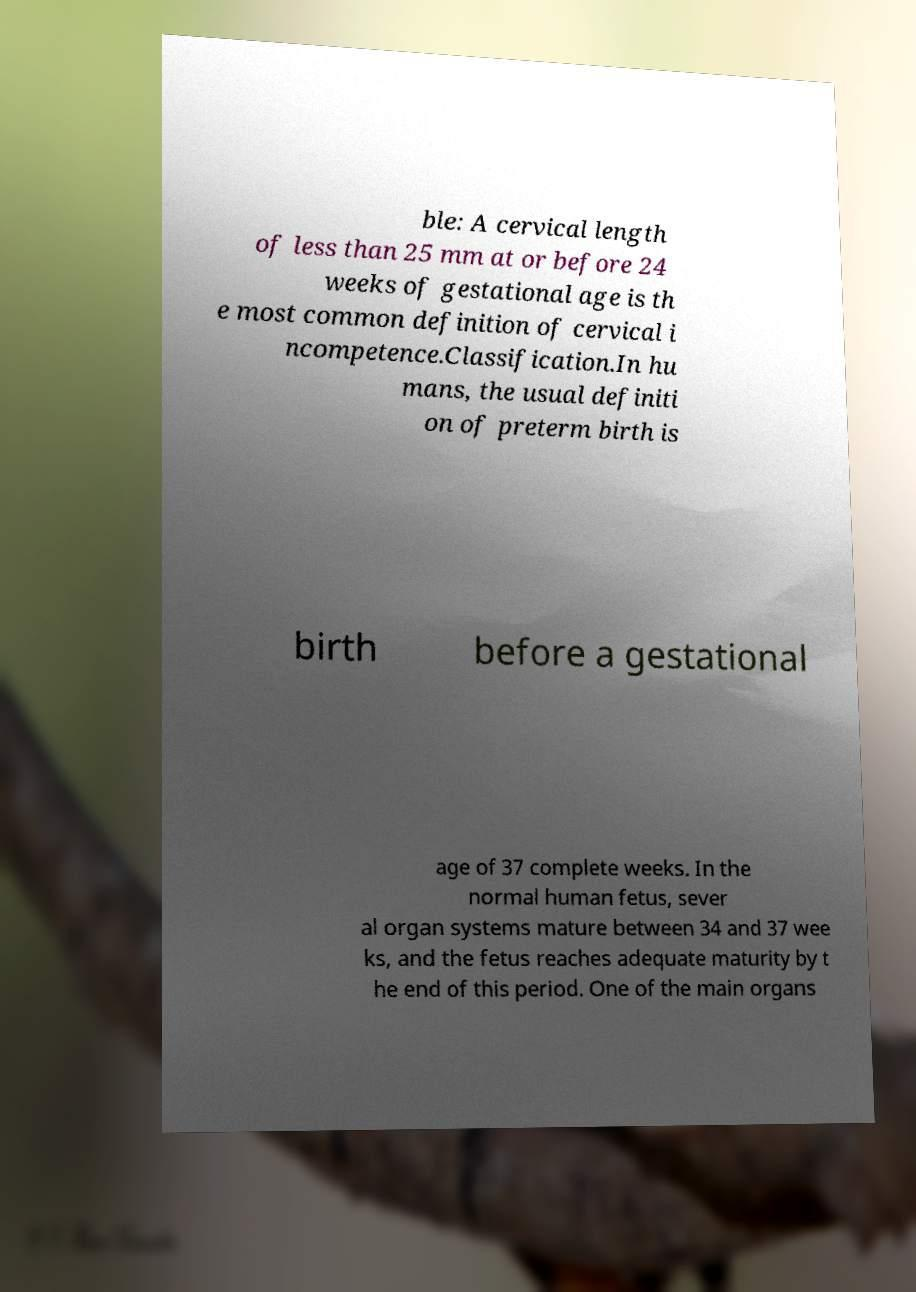Can you accurately transcribe the text from the provided image for me? ble: A cervical length of less than 25 mm at or before 24 weeks of gestational age is th e most common definition of cervical i ncompetence.Classification.In hu mans, the usual definiti on of preterm birth is birth before a gestational age of 37 complete weeks. In the normal human fetus, sever al organ systems mature between 34 and 37 wee ks, and the fetus reaches adequate maturity by t he end of this period. One of the main organs 